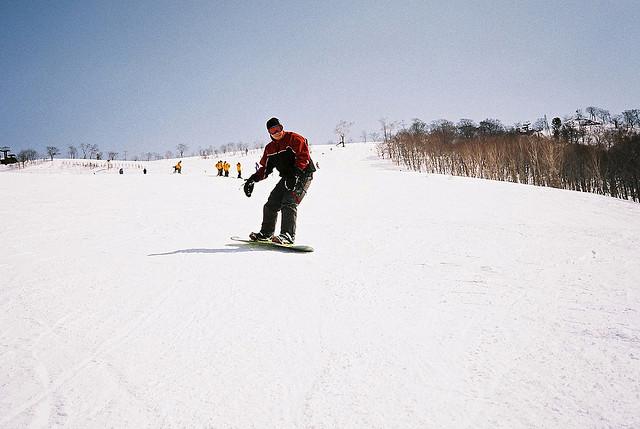Is the man going down a slope?
Keep it brief. Yes. What is the man doing?
Answer briefly. Snowboarding. What is on the man's hands?
Concise answer only. Gloves. 